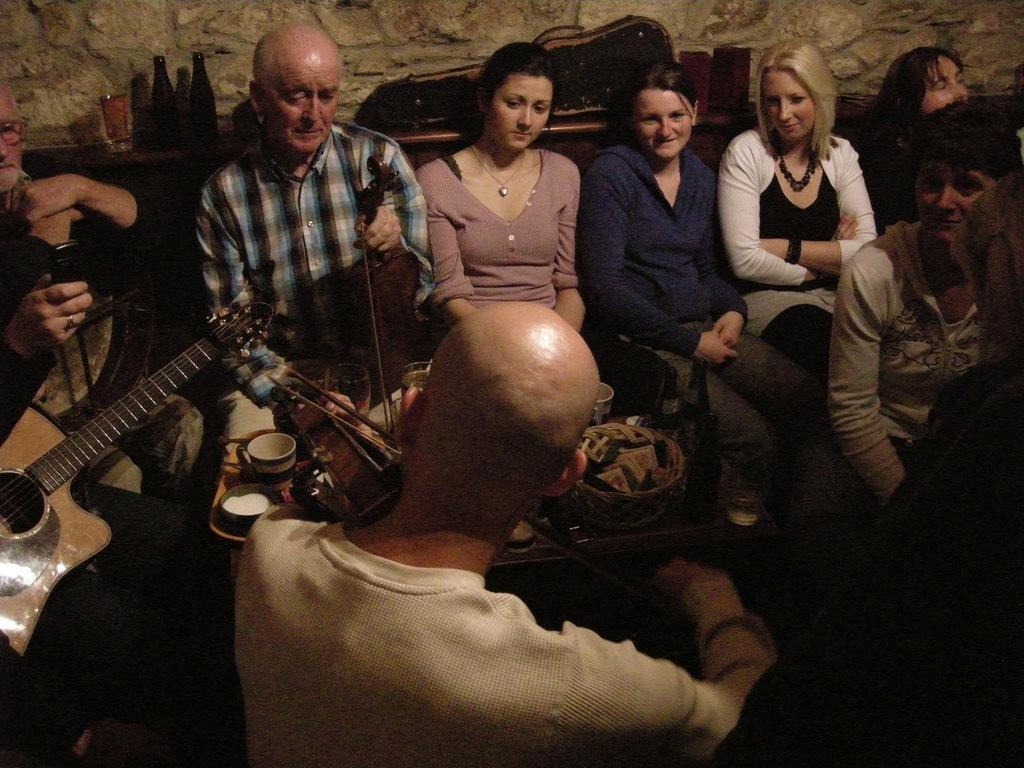Can you describe this image briefly? In this picture we can see a few people sitting. We can see cups, glasses, bottles, a basket and a few things on the table. We can see a person holding an object visible on the left side. There are a few objects and a stone wall is visible in the background. 